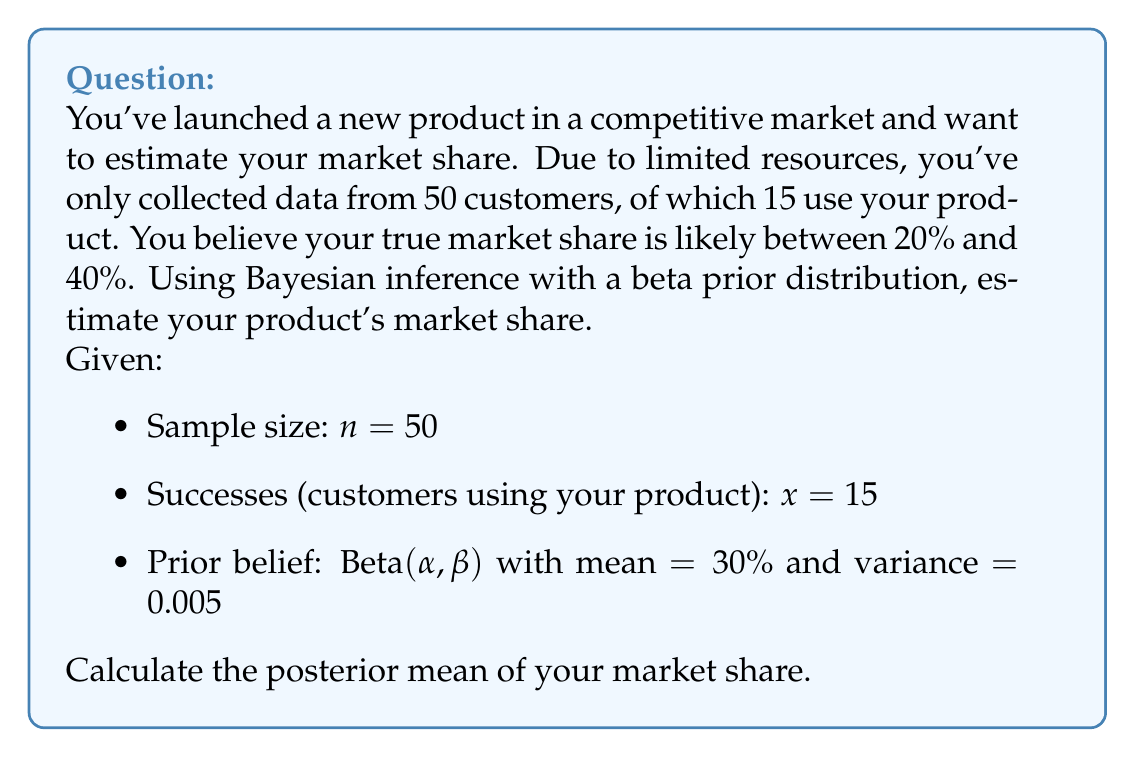Help me with this question. To solve this problem using Bayesian inference with a beta prior distribution, we'll follow these steps:

1. Determine the parameters of the prior beta distribution
2. Update the prior with the observed data
3. Calculate the posterior mean

Step 1: Determine prior parameters

We're given that the prior distribution is Beta(α, β) with mean = 0.30 and variance = 0.005.

For a beta distribution:
Mean = $\frac{\alpha}{\alpha + \beta}$ = 0.30
Variance = $\frac{\alpha\beta}{(\alpha + \beta)^2(\alpha + \beta + 1)}$ = 0.005

Using these equations, we can solve for α and β:

$\frac{\alpha}{\alpha + \beta} = 0.30$
$\frac{\alpha\beta}{(\alpha + \beta)^2(\alpha + \beta + 1)} = 0.005$

Solving this system of equations (which can be done numerically), we get:
α ≈ 17.4
β ≈ 40.6

Step 2: Update the prior with observed data

The posterior distribution is also a beta distribution with parameters:
$\alpha_{posterior} = \alpha_{prior} + x$
$\beta_{posterior} = \beta_{prior} + (n - x)$

Where:
x = number of successes (15)
n = sample size (50)

$\alpha_{posterior} = 17.4 + 15 = 32.4$
$\beta_{posterior} = 40.6 + (50 - 15) = 75.6$

Step 3: Calculate the posterior mean

The posterior mean is given by:

$$\text{Posterior Mean} = \frac{\alpha_{posterior}}{\alpha_{posterior} + \beta_{posterior}}$$

$$\text{Posterior Mean} = \frac{32.4}{32.4 + 75.6} = \frac{32.4}{108} \approx 0.3$$

Therefore, the estimated market share based on the Bayesian inference is approximately 0.3 or 30%.
Answer: The posterior mean of the market share is approximately 0.3 or 30%. 